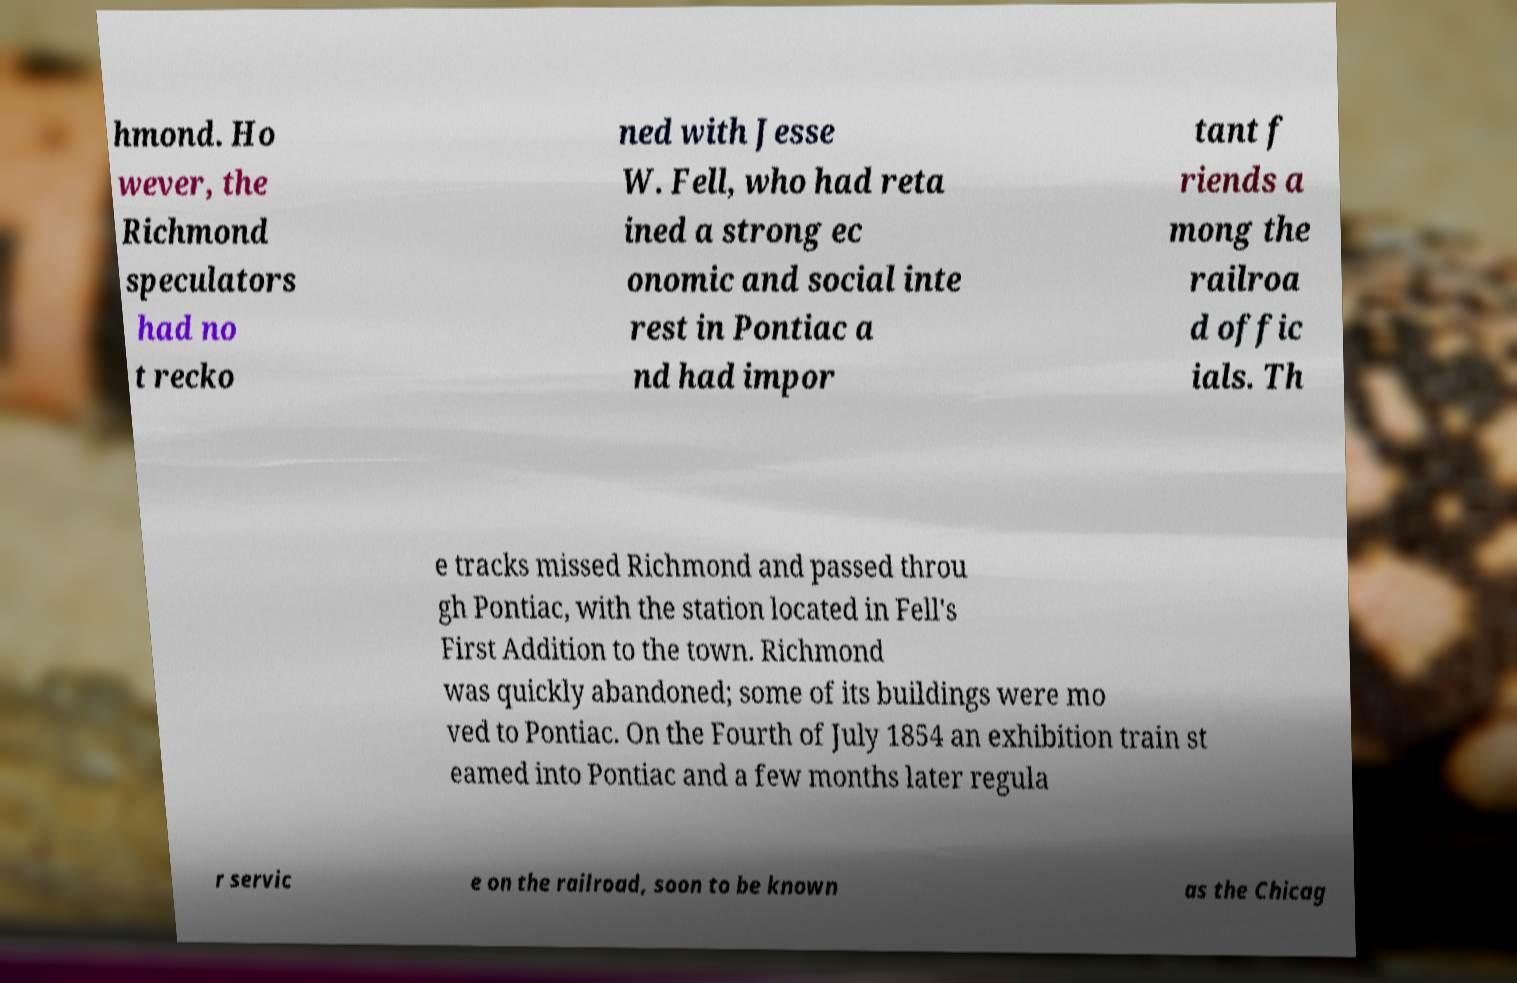I need the written content from this picture converted into text. Can you do that? hmond. Ho wever, the Richmond speculators had no t recko ned with Jesse W. Fell, who had reta ined a strong ec onomic and social inte rest in Pontiac a nd had impor tant f riends a mong the railroa d offic ials. Th e tracks missed Richmond and passed throu gh Pontiac, with the station located in Fell's First Addition to the town. Richmond was quickly abandoned; some of its buildings were mo ved to Pontiac. On the Fourth of July 1854 an exhibition train st eamed into Pontiac and a few months later regula r servic e on the railroad, soon to be known as the Chicag 